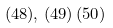Convert formula to latex. <formula><loc_0><loc_0><loc_500><loc_500>( 4 8 ) , \, ( 4 9 ) \, ( 5 0 )</formula> 